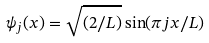Convert formula to latex. <formula><loc_0><loc_0><loc_500><loc_500>\psi _ { j } ( x ) = \sqrt { ( 2 / L ) } \sin ( \pi j x / L )</formula> 